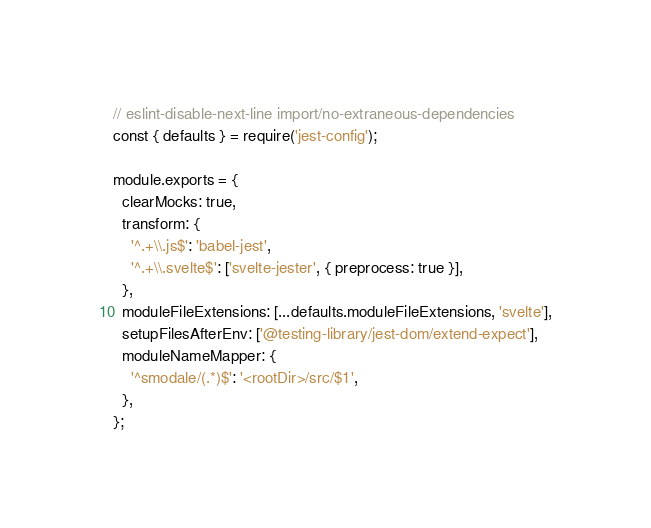Convert code to text. <code><loc_0><loc_0><loc_500><loc_500><_JavaScript_>// eslint-disable-next-line import/no-extraneous-dependencies
const { defaults } = require('jest-config');

module.exports = {
  clearMocks: true,
  transform: {
    '^.+\\.js$': 'babel-jest',
    '^.+\\.svelte$': ['svelte-jester', { preprocess: true }],
  },
  moduleFileExtensions: [...defaults.moduleFileExtensions, 'svelte'],
  setupFilesAfterEnv: ['@testing-library/jest-dom/extend-expect'],
  moduleNameMapper: {
    '^smodale/(.*)$': '<rootDir>/src/$1',
  },
};
</code> 